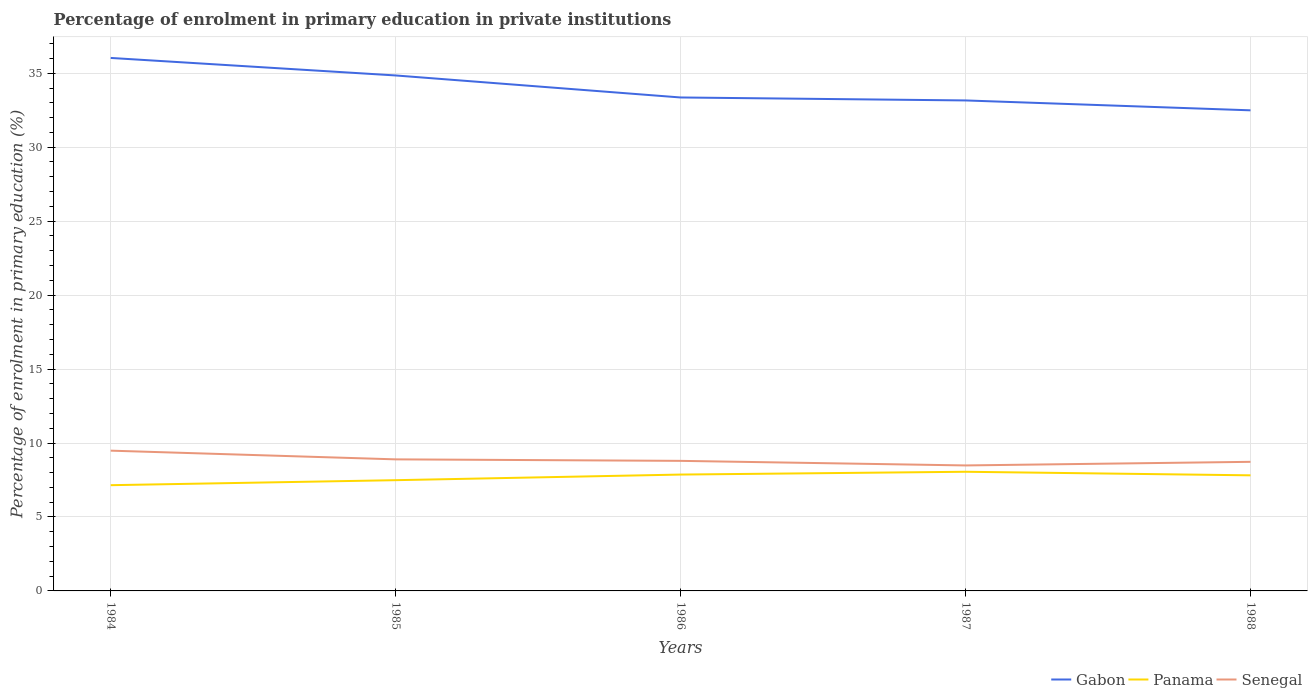Does the line corresponding to Panama intersect with the line corresponding to Senegal?
Offer a very short reply. No. Is the number of lines equal to the number of legend labels?
Offer a very short reply. Yes. Across all years, what is the maximum percentage of enrolment in primary education in Gabon?
Provide a succinct answer. 32.49. What is the total percentage of enrolment in primary education in Gabon in the graph?
Give a very brief answer. 2.87. What is the difference between the highest and the second highest percentage of enrolment in primary education in Senegal?
Provide a succinct answer. 1. Is the percentage of enrolment in primary education in Panama strictly greater than the percentage of enrolment in primary education in Gabon over the years?
Offer a terse response. Yes. Does the graph contain any zero values?
Provide a succinct answer. No. What is the title of the graph?
Give a very brief answer. Percentage of enrolment in primary education in private institutions. Does "Korea (Democratic)" appear as one of the legend labels in the graph?
Your response must be concise. No. What is the label or title of the X-axis?
Offer a very short reply. Years. What is the label or title of the Y-axis?
Give a very brief answer. Percentage of enrolment in primary education (%). What is the Percentage of enrolment in primary education (%) in Gabon in 1984?
Your answer should be compact. 36.03. What is the Percentage of enrolment in primary education (%) in Panama in 1984?
Make the answer very short. 7.15. What is the Percentage of enrolment in primary education (%) in Senegal in 1984?
Offer a terse response. 9.48. What is the Percentage of enrolment in primary education (%) in Gabon in 1985?
Keep it short and to the point. 34.85. What is the Percentage of enrolment in primary education (%) of Panama in 1985?
Keep it short and to the point. 7.49. What is the Percentage of enrolment in primary education (%) in Senegal in 1985?
Provide a short and direct response. 8.89. What is the Percentage of enrolment in primary education (%) in Gabon in 1986?
Provide a succinct answer. 33.36. What is the Percentage of enrolment in primary education (%) in Panama in 1986?
Your response must be concise. 7.87. What is the Percentage of enrolment in primary education (%) of Senegal in 1986?
Give a very brief answer. 8.79. What is the Percentage of enrolment in primary education (%) of Gabon in 1987?
Your response must be concise. 33.16. What is the Percentage of enrolment in primary education (%) in Panama in 1987?
Your answer should be very brief. 8.06. What is the Percentage of enrolment in primary education (%) in Senegal in 1987?
Provide a succinct answer. 8.48. What is the Percentage of enrolment in primary education (%) of Gabon in 1988?
Make the answer very short. 32.49. What is the Percentage of enrolment in primary education (%) of Panama in 1988?
Provide a succinct answer. 7.81. What is the Percentage of enrolment in primary education (%) in Senegal in 1988?
Your response must be concise. 8.73. Across all years, what is the maximum Percentage of enrolment in primary education (%) of Gabon?
Provide a short and direct response. 36.03. Across all years, what is the maximum Percentage of enrolment in primary education (%) in Panama?
Provide a short and direct response. 8.06. Across all years, what is the maximum Percentage of enrolment in primary education (%) of Senegal?
Give a very brief answer. 9.48. Across all years, what is the minimum Percentage of enrolment in primary education (%) of Gabon?
Your response must be concise. 32.49. Across all years, what is the minimum Percentage of enrolment in primary education (%) in Panama?
Make the answer very short. 7.15. Across all years, what is the minimum Percentage of enrolment in primary education (%) in Senegal?
Keep it short and to the point. 8.48. What is the total Percentage of enrolment in primary education (%) of Gabon in the graph?
Make the answer very short. 169.9. What is the total Percentage of enrolment in primary education (%) in Panama in the graph?
Your answer should be very brief. 38.37. What is the total Percentage of enrolment in primary education (%) in Senegal in the graph?
Offer a terse response. 44.38. What is the difference between the Percentage of enrolment in primary education (%) in Gabon in 1984 and that in 1985?
Keep it short and to the point. 1.18. What is the difference between the Percentage of enrolment in primary education (%) in Panama in 1984 and that in 1985?
Make the answer very short. -0.34. What is the difference between the Percentage of enrolment in primary education (%) in Senegal in 1984 and that in 1985?
Give a very brief answer. 0.59. What is the difference between the Percentage of enrolment in primary education (%) of Gabon in 1984 and that in 1986?
Provide a short and direct response. 2.67. What is the difference between the Percentage of enrolment in primary education (%) in Panama in 1984 and that in 1986?
Give a very brief answer. -0.72. What is the difference between the Percentage of enrolment in primary education (%) in Senegal in 1984 and that in 1986?
Give a very brief answer. 0.69. What is the difference between the Percentage of enrolment in primary education (%) in Gabon in 1984 and that in 1987?
Make the answer very short. 2.87. What is the difference between the Percentage of enrolment in primary education (%) of Panama in 1984 and that in 1987?
Provide a short and direct response. -0.91. What is the difference between the Percentage of enrolment in primary education (%) in Senegal in 1984 and that in 1987?
Give a very brief answer. 1. What is the difference between the Percentage of enrolment in primary education (%) of Gabon in 1984 and that in 1988?
Keep it short and to the point. 3.54. What is the difference between the Percentage of enrolment in primary education (%) of Panama in 1984 and that in 1988?
Your answer should be very brief. -0.67. What is the difference between the Percentage of enrolment in primary education (%) of Senegal in 1984 and that in 1988?
Make the answer very short. 0.76. What is the difference between the Percentage of enrolment in primary education (%) of Gabon in 1985 and that in 1986?
Provide a succinct answer. 1.49. What is the difference between the Percentage of enrolment in primary education (%) in Panama in 1985 and that in 1986?
Offer a terse response. -0.38. What is the difference between the Percentage of enrolment in primary education (%) in Senegal in 1985 and that in 1986?
Offer a terse response. 0.1. What is the difference between the Percentage of enrolment in primary education (%) of Gabon in 1985 and that in 1987?
Offer a very short reply. 1.69. What is the difference between the Percentage of enrolment in primary education (%) in Panama in 1985 and that in 1987?
Give a very brief answer. -0.57. What is the difference between the Percentage of enrolment in primary education (%) in Senegal in 1985 and that in 1987?
Make the answer very short. 0.41. What is the difference between the Percentage of enrolment in primary education (%) in Gabon in 1985 and that in 1988?
Offer a very short reply. 2.36. What is the difference between the Percentage of enrolment in primary education (%) in Panama in 1985 and that in 1988?
Ensure brevity in your answer.  -0.33. What is the difference between the Percentage of enrolment in primary education (%) of Senegal in 1985 and that in 1988?
Make the answer very short. 0.17. What is the difference between the Percentage of enrolment in primary education (%) of Gabon in 1986 and that in 1987?
Offer a terse response. 0.2. What is the difference between the Percentage of enrolment in primary education (%) in Panama in 1986 and that in 1987?
Ensure brevity in your answer.  -0.19. What is the difference between the Percentage of enrolment in primary education (%) of Senegal in 1986 and that in 1987?
Ensure brevity in your answer.  0.31. What is the difference between the Percentage of enrolment in primary education (%) in Gabon in 1986 and that in 1988?
Provide a short and direct response. 0.87. What is the difference between the Percentage of enrolment in primary education (%) in Panama in 1986 and that in 1988?
Your answer should be compact. 0.05. What is the difference between the Percentage of enrolment in primary education (%) of Senegal in 1986 and that in 1988?
Keep it short and to the point. 0.07. What is the difference between the Percentage of enrolment in primary education (%) of Gabon in 1987 and that in 1988?
Your answer should be very brief. 0.67. What is the difference between the Percentage of enrolment in primary education (%) in Panama in 1987 and that in 1988?
Give a very brief answer. 0.24. What is the difference between the Percentage of enrolment in primary education (%) in Senegal in 1987 and that in 1988?
Ensure brevity in your answer.  -0.24. What is the difference between the Percentage of enrolment in primary education (%) in Gabon in 1984 and the Percentage of enrolment in primary education (%) in Panama in 1985?
Keep it short and to the point. 28.55. What is the difference between the Percentage of enrolment in primary education (%) of Gabon in 1984 and the Percentage of enrolment in primary education (%) of Senegal in 1985?
Make the answer very short. 27.14. What is the difference between the Percentage of enrolment in primary education (%) of Panama in 1984 and the Percentage of enrolment in primary education (%) of Senegal in 1985?
Provide a succinct answer. -1.75. What is the difference between the Percentage of enrolment in primary education (%) of Gabon in 1984 and the Percentage of enrolment in primary education (%) of Panama in 1986?
Offer a very short reply. 28.17. What is the difference between the Percentage of enrolment in primary education (%) in Gabon in 1984 and the Percentage of enrolment in primary education (%) in Senegal in 1986?
Offer a very short reply. 27.24. What is the difference between the Percentage of enrolment in primary education (%) of Panama in 1984 and the Percentage of enrolment in primary education (%) of Senegal in 1986?
Give a very brief answer. -1.64. What is the difference between the Percentage of enrolment in primary education (%) in Gabon in 1984 and the Percentage of enrolment in primary education (%) in Panama in 1987?
Provide a short and direct response. 27.98. What is the difference between the Percentage of enrolment in primary education (%) of Gabon in 1984 and the Percentage of enrolment in primary education (%) of Senegal in 1987?
Ensure brevity in your answer.  27.55. What is the difference between the Percentage of enrolment in primary education (%) of Panama in 1984 and the Percentage of enrolment in primary education (%) of Senegal in 1987?
Keep it short and to the point. -1.33. What is the difference between the Percentage of enrolment in primary education (%) in Gabon in 1984 and the Percentage of enrolment in primary education (%) in Panama in 1988?
Keep it short and to the point. 28.22. What is the difference between the Percentage of enrolment in primary education (%) of Gabon in 1984 and the Percentage of enrolment in primary education (%) of Senegal in 1988?
Make the answer very short. 27.31. What is the difference between the Percentage of enrolment in primary education (%) in Panama in 1984 and the Percentage of enrolment in primary education (%) in Senegal in 1988?
Make the answer very short. -1.58. What is the difference between the Percentage of enrolment in primary education (%) of Gabon in 1985 and the Percentage of enrolment in primary education (%) of Panama in 1986?
Your answer should be compact. 26.98. What is the difference between the Percentage of enrolment in primary education (%) in Gabon in 1985 and the Percentage of enrolment in primary education (%) in Senegal in 1986?
Ensure brevity in your answer.  26.06. What is the difference between the Percentage of enrolment in primary education (%) in Panama in 1985 and the Percentage of enrolment in primary education (%) in Senegal in 1986?
Ensure brevity in your answer.  -1.31. What is the difference between the Percentage of enrolment in primary education (%) in Gabon in 1985 and the Percentage of enrolment in primary education (%) in Panama in 1987?
Keep it short and to the point. 26.79. What is the difference between the Percentage of enrolment in primary education (%) of Gabon in 1985 and the Percentage of enrolment in primary education (%) of Senegal in 1987?
Ensure brevity in your answer.  26.37. What is the difference between the Percentage of enrolment in primary education (%) in Panama in 1985 and the Percentage of enrolment in primary education (%) in Senegal in 1987?
Keep it short and to the point. -1. What is the difference between the Percentage of enrolment in primary education (%) in Gabon in 1985 and the Percentage of enrolment in primary education (%) in Panama in 1988?
Give a very brief answer. 27.04. What is the difference between the Percentage of enrolment in primary education (%) of Gabon in 1985 and the Percentage of enrolment in primary education (%) of Senegal in 1988?
Your answer should be very brief. 26.12. What is the difference between the Percentage of enrolment in primary education (%) in Panama in 1985 and the Percentage of enrolment in primary education (%) in Senegal in 1988?
Keep it short and to the point. -1.24. What is the difference between the Percentage of enrolment in primary education (%) in Gabon in 1986 and the Percentage of enrolment in primary education (%) in Panama in 1987?
Give a very brief answer. 25.3. What is the difference between the Percentage of enrolment in primary education (%) in Gabon in 1986 and the Percentage of enrolment in primary education (%) in Senegal in 1987?
Provide a succinct answer. 24.88. What is the difference between the Percentage of enrolment in primary education (%) in Panama in 1986 and the Percentage of enrolment in primary education (%) in Senegal in 1987?
Offer a very short reply. -0.62. What is the difference between the Percentage of enrolment in primary education (%) in Gabon in 1986 and the Percentage of enrolment in primary education (%) in Panama in 1988?
Provide a short and direct response. 25.55. What is the difference between the Percentage of enrolment in primary education (%) in Gabon in 1986 and the Percentage of enrolment in primary education (%) in Senegal in 1988?
Make the answer very short. 24.63. What is the difference between the Percentage of enrolment in primary education (%) of Panama in 1986 and the Percentage of enrolment in primary education (%) of Senegal in 1988?
Your answer should be very brief. -0.86. What is the difference between the Percentage of enrolment in primary education (%) of Gabon in 1987 and the Percentage of enrolment in primary education (%) of Panama in 1988?
Your answer should be very brief. 25.35. What is the difference between the Percentage of enrolment in primary education (%) in Gabon in 1987 and the Percentage of enrolment in primary education (%) in Senegal in 1988?
Your answer should be compact. 24.43. What is the difference between the Percentage of enrolment in primary education (%) of Panama in 1987 and the Percentage of enrolment in primary education (%) of Senegal in 1988?
Your answer should be compact. -0.67. What is the average Percentage of enrolment in primary education (%) in Gabon per year?
Give a very brief answer. 33.98. What is the average Percentage of enrolment in primary education (%) in Panama per year?
Your answer should be very brief. 7.67. What is the average Percentage of enrolment in primary education (%) of Senegal per year?
Make the answer very short. 8.88. In the year 1984, what is the difference between the Percentage of enrolment in primary education (%) in Gabon and Percentage of enrolment in primary education (%) in Panama?
Ensure brevity in your answer.  28.89. In the year 1984, what is the difference between the Percentage of enrolment in primary education (%) of Gabon and Percentage of enrolment in primary education (%) of Senegal?
Keep it short and to the point. 26.55. In the year 1984, what is the difference between the Percentage of enrolment in primary education (%) in Panama and Percentage of enrolment in primary education (%) in Senegal?
Your response must be concise. -2.33. In the year 1985, what is the difference between the Percentage of enrolment in primary education (%) of Gabon and Percentage of enrolment in primary education (%) of Panama?
Offer a very short reply. 27.36. In the year 1985, what is the difference between the Percentage of enrolment in primary education (%) in Gabon and Percentage of enrolment in primary education (%) in Senegal?
Make the answer very short. 25.95. In the year 1985, what is the difference between the Percentage of enrolment in primary education (%) in Panama and Percentage of enrolment in primary education (%) in Senegal?
Offer a very short reply. -1.41. In the year 1986, what is the difference between the Percentage of enrolment in primary education (%) in Gabon and Percentage of enrolment in primary education (%) in Panama?
Your answer should be compact. 25.49. In the year 1986, what is the difference between the Percentage of enrolment in primary education (%) of Gabon and Percentage of enrolment in primary education (%) of Senegal?
Make the answer very short. 24.57. In the year 1986, what is the difference between the Percentage of enrolment in primary education (%) in Panama and Percentage of enrolment in primary education (%) in Senegal?
Your response must be concise. -0.93. In the year 1987, what is the difference between the Percentage of enrolment in primary education (%) of Gabon and Percentage of enrolment in primary education (%) of Panama?
Offer a terse response. 25.1. In the year 1987, what is the difference between the Percentage of enrolment in primary education (%) in Gabon and Percentage of enrolment in primary education (%) in Senegal?
Your answer should be compact. 24.68. In the year 1987, what is the difference between the Percentage of enrolment in primary education (%) of Panama and Percentage of enrolment in primary education (%) of Senegal?
Provide a short and direct response. -0.43. In the year 1988, what is the difference between the Percentage of enrolment in primary education (%) of Gabon and Percentage of enrolment in primary education (%) of Panama?
Your answer should be very brief. 24.68. In the year 1988, what is the difference between the Percentage of enrolment in primary education (%) of Gabon and Percentage of enrolment in primary education (%) of Senegal?
Your answer should be very brief. 23.76. In the year 1988, what is the difference between the Percentage of enrolment in primary education (%) in Panama and Percentage of enrolment in primary education (%) in Senegal?
Give a very brief answer. -0.91. What is the ratio of the Percentage of enrolment in primary education (%) of Gabon in 1984 to that in 1985?
Your answer should be very brief. 1.03. What is the ratio of the Percentage of enrolment in primary education (%) of Panama in 1984 to that in 1985?
Your answer should be compact. 0.95. What is the ratio of the Percentage of enrolment in primary education (%) in Senegal in 1984 to that in 1985?
Offer a terse response. 1.07. What is the ratio of the Percentage of enrolment in primary education (%) in Gabon in 1984 to that in 1986?
Make the answer very short. 1.08. What is the ratio of the Percentage of enrolment in primary education (%) in Panama in 1984 to that in 1986?
Keep it short and to the point. 0.91. What is the ratio of the Percentage of enrolment in primary education (%) in Senegal in 1984 to that in 1986?
Provide a short and direct response. 1.08. What is the ratio of the Percentage of enrolment in primary education (%) of Gabon in 1984 to that in 1987?
Offer a terse response. 1.09. What is the ratio of the Percentage of enrolment in primary education (%) of Panama in 1984 to that in 1987?
Your response must be concise. 0.89. What is the ratio of the Percentage of enrolment in primary education (%) of Senegal in 1984 to that in 1987?
Make the answer very short. 1.12. What is the ratio of the Percentage of enrolment in primary education (%) of Gabon in 1984 to that in 1988?
Give a very brief answer. 1.11. What is the ratio of the Percentage of enrolment in primary education (%) in Panama in 1984 to that in 1988?
Keep it short and to the point. 0.91. What is the ratio of the Percentage of enrolment in primary education (%) of Senegal in 1984 to that in 1988?
Make the answer very short. 1.09. What is the ratio of the Percentage of enrolment in primary education (%) of Gabon in 1985 to that in 1986?
Offer a terse response. 1.04. What is the ratio of the Percentage of enrolment in primary education (%) of Panama in 1985 to that in 1986?
Your answer should be very brief. 0.95. What is the ratio of the Percentage of enrolment in primary education (%) in Senegal in 1985 to that in 1986?
Your answer should be very brief. 1.01. What is the ratio of the Percentage of enrolment in primary education (%) of Gabon in 1985 to that in 1987?
Offer a very short reply. 1.05. What is the ratio of the Percentage of enrolment in primary education (%) of Panama in 1985 to that in 1987?
Offer a very short reply. 0.93. What is the ratio of the Percentage of enrolment in primary education (%) of Senegal in 1985 to that in 1987?
Your answer should be very brief. 1.05. What is the ratio of the Percentage of enrolment in primary education (%) in Gabon in 1985 to that in 1988?
Offer a terse response. 1.07. What is the ratio of the Percentage of enrolment in primary education (%) in Panama in 1985 to that in 1988?
Offer a terse response. 0.96. What is the ratio of the Percentage of enrolment in primary education (%) in Senegal in 1985 to that in 1988?
Your response must be concise. 1.02. What is the ratio of the Percentage of enrolment in primary education (%) of Panama in 1986 to that in 1987?
Provide a short and direct response. 0.98. What is the ratio of the Percentage of enrolment in primary education (%) in Senegal in 1986 to that in 1987?
Make the answer very short. 1.04. What is the ratio of the Percentage of enrolment in primary education (%) in Gabon in 1986 to that in 1988?
Provide a short and direct response. 1.03. What is the ratio of the Percentage of enrolment in primary education (%) of Senegal in 1986 to that in 1988?
Offer a terse response. 1.01. What is the ratio of the Percentage of enrolment in primary education (%) in Gabon in 1987 to that in 1988?
Provide a succinct answer. 1.02. What is the ratio of the Percentage of enrolment in primary education (%) in Panama in 1987 to that in 1988?
Provide a short and direct response. 1.03. What is the ratio of the Percentage of enrolment in primary education (%) of Senegal in 1987 to that in 1988?
Offer a terse response. 0.97. What is the difference between the highest and the second highest Percentage of enrolment in primary education (%) in Gabon?
Your answer should be compact. 1.18. What is the difference between the highest and the second highest Percentage of enrolment in primary education (%) of Panama?
Offer a very short reply. 0.19. What is the difference between the highest and the second highest Percentage of enrolment in primary education (%) in Senegal?
Keep it short and to the point. 0.59. What is the difference between the highest and the lowest Percentage of enrolment in primary education (%) in Gabon?
Ensure brevity in your answer.  3.54. What is the difference between the highest and the lowest Percentage of enrolment in primary education (%) of Panama?
Provide a succinct answer. 0.91. 